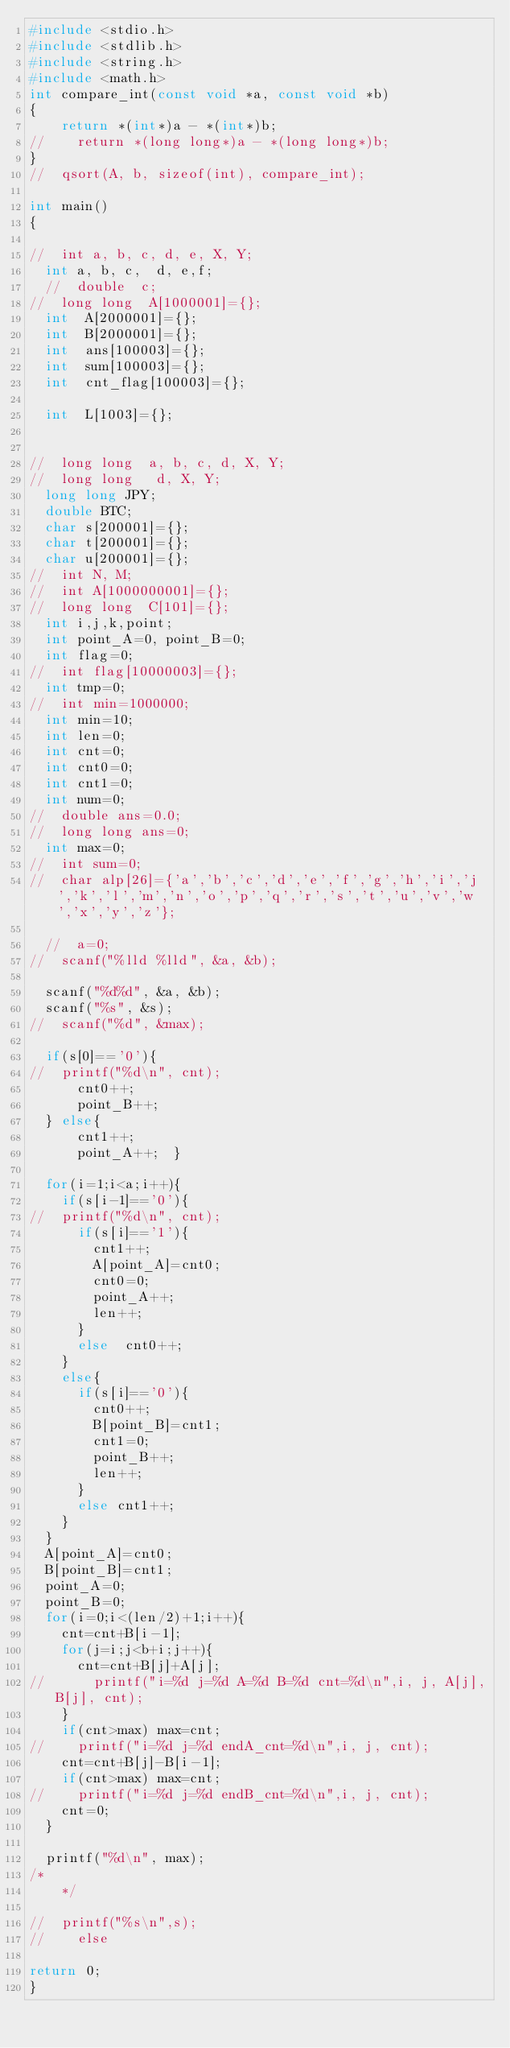Convert code to text. <code><loc_0><loc_0><loc_500><loc_500><_C_>#include <stdio.h>
#include <stdlib.h>
#include <string.h>
#include <math.h>
int compare_int(const void *a, const void *b)
{
    return *(int*)a - *(int*)b;
//    return *(long long*)a - *(long long*)b;
}
//  qsort(A, b, sizeof(int), compare_int);

int main()
{
 
//  int a, b, c, d, e, X, Y;
  int a, b, c,  d, e,f;
  //  double  c;
//  long long  A[1000001]={};
  int  A[2000001]={};
  int  B[2000001]={};
  int  ans[100003]={};
  int  sum[100003]={};
  int  cnt_flag[100003]={};

  int  L[1003]={};


//  long long  a, b, c, d, X, Y;
//  long long   d, X, Y;
  long long JPY;
  double BTC;
  char s[200001]={};
  char t[200001]={};
  char u[200001]={};
//  int N, M;
//  int A[1000000001]={};
//  long long  C[101]={};
  int i,j,k,point;
  int point_A=0, point_B=0;
  int flag=0;
//  int flag[10000003]={};
  int tmp=0;
//  int min=1000000;
  int min=10;
  int len=0;
  int cnt=0;
  int cnt0=0;
  int cnt1=0;
  int num=0;
//  double ans=0.0;
//  long long ans=0;
  int max=0;
//  int sum=0;
//  char alp[26]={'a','b','c','d','e','f','g','h','i','j','k','l','m','n','o','p','q','r','s','t','u','v','w','x','y','z'};

  //  a=0;
//  scanf("%lld %lld", &a, &b);
 
  scanf("%d%d", &a, &b);
  scanf("%s", &s);
//  scanf("%d", &max);

  if(s[0]=='0'){
//  printf("%d\n", cnt);
      cnt0++;
      point_B++;
  } else{
      cnt1++;
      point_A++;  }

  for(i=1;i<a;i++){
    if(s[i-1]=='0'){
//  printf("%d\n", cnt);
      if(s[i]=='1'){
        cnt1++;
        A[point_A]=cnt0;
        cnt0=0;
        point_A++;
        len++;
      }
      else  cnt0++;
    }
    else{
      if(s[i]=='0'){
        cnt0++;
        B[point_B]=cnt1;
        cnt1=0;
        point_B++;
        len++;
      }
      else cnt1++;
    }
  }
  A[point_A]=cnt0;
  B[point_B]=cnt1;
  point_A=0;
  point_B=0;
  for(i=0;i<(len/2)+1;i++){
    cnt=cnt+B[i-1];
    for(j=i;j<b+i;j++){
      cnt=cnt+B[j]+A[j];
//      printf("i=%d j=%d A=%d B=%d cnt=%d\n",i, j, A[j],B[j], cnt);
    }
    if(cnt>max) max=cnt;
//    printf("i=%d j=%d endA_cnt=%d\n",i, j, cnt);
    cnt=cnt+B[j]-B[i-1];
    if(cnt>max) max=cnt;
//    printf("i=%d j=%d endB_cnt=%d\n",i, j, cnt);
    cnt=0;
  }
  
  printf("%d\n", max);
/*    
    */

//  printf("%s\n",s);
//    else  
  
return 0;
}
</code> 